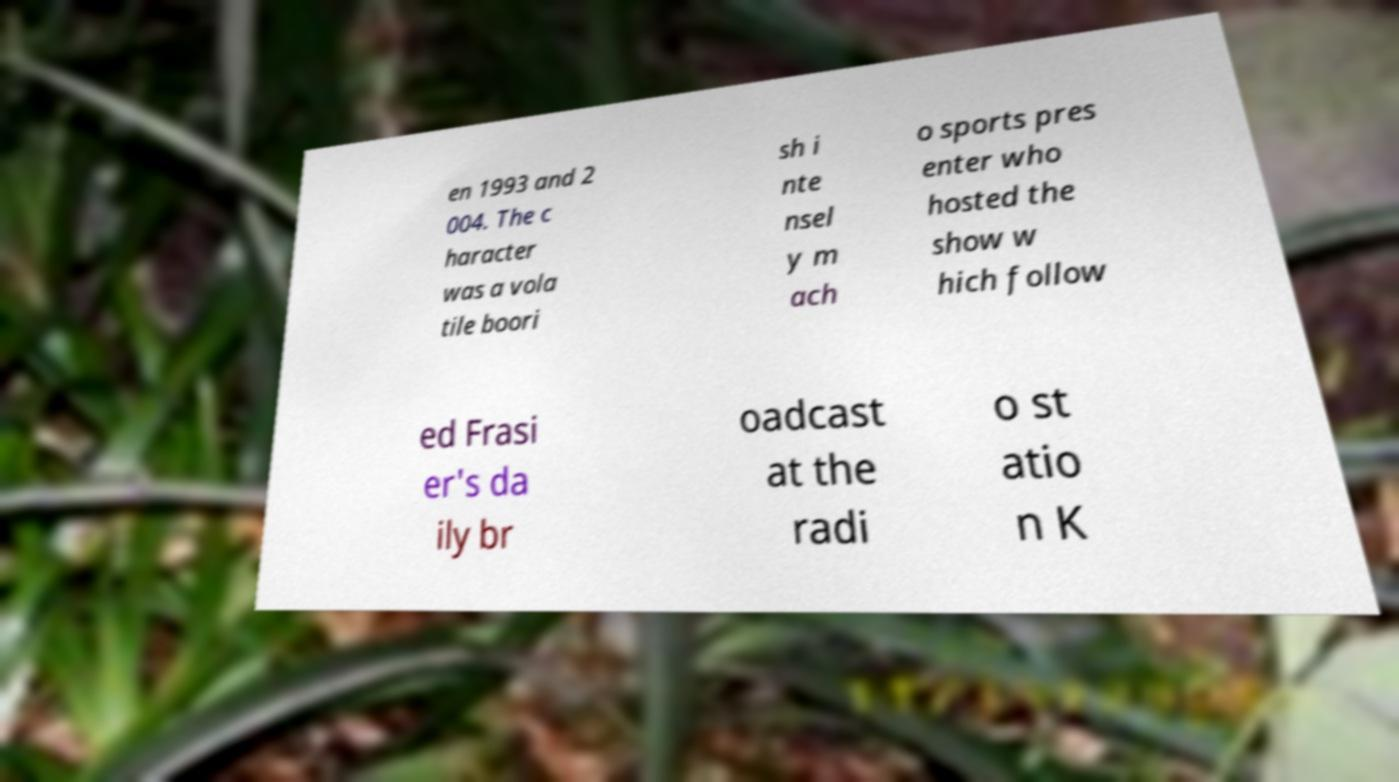Can you accurately transcribe the text from the provided image for me? en 1993 and 2 004. The c haracter was a vola tile boori sh i nte nsel y m ach o sports pres enter who hosted the show w hich follow ed Frasi er's da ily br oadcast at the radi o st atio n K 